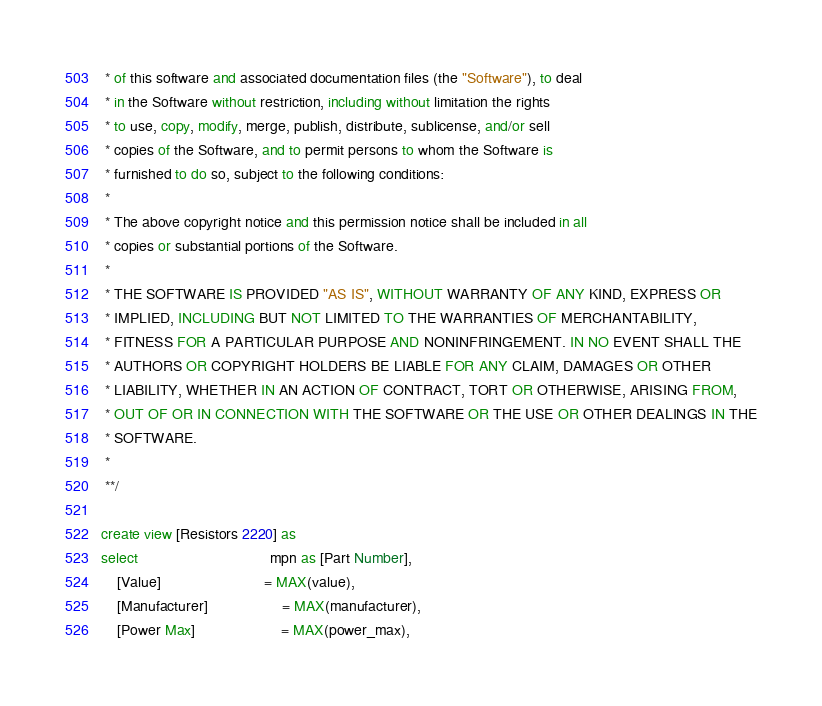<code> <loc_0><loc_0><loc_500><loc_500><_SQL_> * of this software and associated documentation files (the "Software"), to deal
 * in the Software without restriction, including without limitation the rights
 * to use, copy, modify, merge, publish, distribute, sublicense, and/or sell
 * copies of the Software, and to permit persons to whom the Software is
 * furnished to do so, subject to the following conditions:
 *
 * The above copyright notice and this permission notice shall be included in all
 * copies or substantial portions of the Software.
 *
 * THE SOFTWARE IS PROVIDED "AS IS", WITHOUT WARRANTY OF ANY KIND, EXPRESS OR
 * IMPLIED, INCLUDING BUT NOT LIMITED TO THE WARRANTIES OF MERCHANTABILITY,
 * FITNESS FOR A PARTICULAR PURPOSE AND NONINFRINGEMENT. IN NO EVENT SHALL THE
 * AUTHORS OR COPYRIGHT HOLDERS BE LIABLE FOR ANY CLAIM, DAMAGES OR OTHER
 * LIABILITY, WHETHER IN AN ACTION OF CONTRACT, TORT OR OTHERWISE, ARISING FROM,
 * OUT OF OR IN CONNECTION WITH THE SOFTWARE OR THE USE OR OTHER DEALINGS IN THE
 * SOFTWARE.
 *
 **/

create view [Resistors 2220] as
select                                mpn as [Part Number],
    [Value]                         = MAX(value),
    [Manufacturer]                  = MAX(manufacturer),
    [Power Max]                     = MAX(power_max),</code> 